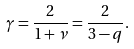Convert formula to latex. <formula><loc_0><loc_0><loc_500><loc_500>\gamma = \frac { 2 } { 1 + \nu } = \frac { 2 } { 3 - q } .</formula> 